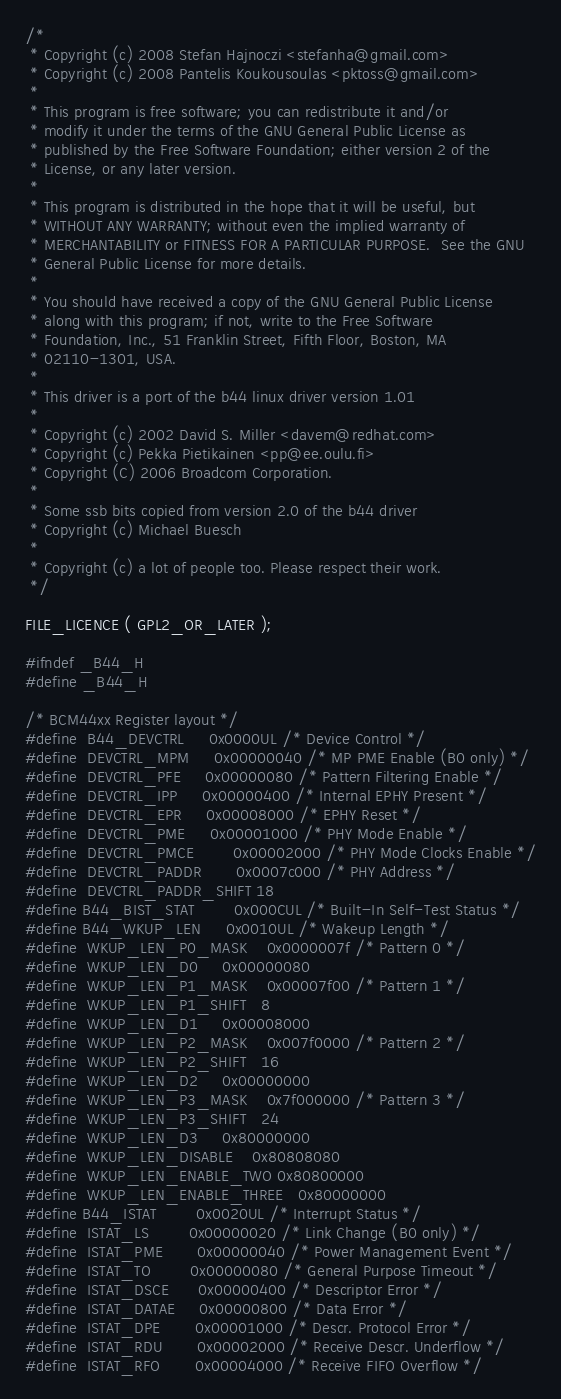<code> <loc_0><loc_0><loc_500><loc_500><_C_>/*
 * Copyright (c) 2008 Stefan Hajnoczi <stefanha@gmail.com>
 * Copyright (c) 2008 Pantelis Koukousoulas <pktoss@gmail.com>
 *
 * This program is free software; you can redistribute it and/or
 * modify it under the terms of the GNU General Public License as
 * published by the Free Software Foundation; either version 2 of the
 * License, or any later version.
 *
 * This program is distributed in the hope that it will be useful, but
 * WITHOUT ANY WARRANTY; without even the implied warranty of
 * MERCHANTABILITY or FITNESS FOR A PARTICULAR PURPOSE.  See the GNU
 * General Public License for more details.
 *
 * You should have received a copy of the GNU General Public License
 * along with this program; if not, write to the Free Software
 * Foundation, Inc., 51 Franklin Street, Fifth Floor, Boston, MA
 * 02110-1301, USA.
 *
 * This driver is a port of the b44 linux driver version 1.01
 *
 * Copyright (c) 2002 David S. Miller <davem@redhat.com>
 * Copyright (c) Pekka Pietikainen <pp@ee.oulu.fi>
 * Copyright (C) 2006 Broadcom Corporation.
 *
 * Some ssb bits copied from version 2.0 of the b44 driver
 * Copyright (c) Michael Buesch
 *
 * Copyright (c) a lot of people too. Please respect their work.
 */

FILE_LICENCE ( GPL2_OR_LATER );

#ifndef _B44_H
#define _B44_H

/* BCM44xx Register layout */
#define	B44_DEVCTRL		0x0000UL /* Device Control */
#define  DEVCTRL_MPM		0x00000040 /* MP PME Enable (B0 only) */
#define  DEVCTRL_PFE		0x00000080 /* Pattern Filtering Enable */
#define  DEVCTRL_IPP		0x00000400 /* Internal EPHY Present */
#define  DEVCTRL_EPR		0x00008000 /* EPHY Reset */
#define  DEVCTRL_PME		0x00001000 /* PHY Mode Enable */
#define  DEVCTRL_PMCE		0x00002000 /* PHY Mode Clocks Enable */
#define  DEVCTRL_PADDR		0x0007c000 /* PHY Address */
#define  DEVCTRL_PADDR_SHIFT	18
#define B44_BIST_STAT		0x000CUL /* Built-In Self-Test Status */
#define B44_WKUP_LEN		0x0010UL /* Wakeup Length */
#define  WKUP_LEN_P0_MASK	0x0000007f /* Pattern 0 */
#define  WKUP_LEN_D0		0x00000080
#define  WKUP_LEN_P1_MASK	0x00007f00 /* Pattern 1 */
#define  WKUP_LEN_P1_SHIFT	8
#define  WKUP_LEN_D1		0x00008000
#define  WKUP_LEN_P2_MASK	0x007f0000 /* Pattern 2 */
#define  WKUP_LEN_P2_SHIFT	16
#define  WKUP_LEN_D2		0x00000000
#define  WKUP_LEN_P3_MASK	0x7f000000 /* Pattern 3 */
#define  WKUP_LEN_P3_SHIFT	24
#define  WKUP_LEN_D3		0x80000000
#define  WKUP_LEN_DISABLE	0x80808080
#define  WKUP_LEN_ENABLE_TWO	0x80800000
#define  WKUP_LEN_ENABLE_THREE	0x80000000
#define B44_ISTAT		0x0020UL /* Interrupt Status */
#define  ISTAT_LS		0x00000020 /* Link Change (B0 only) */
#define  ISTAT_PME		0x00000040 /* Power Management Event */
#define  ISTAT_TO		0x00000080 /* General Purpose Timeout */
#define  ISTAT_DSCE		0x00000400 /* Descriptor Error */
#define  ISTAT_DATAE		0x00000800 /* Data Error */
#define  ISTAT_DPE		0x00001000 /* Descr. Protocol Error */
#define  ISTAT_RDU		0x00002000 /* Receive Descr. Underflow */
#define  ISTAT_RFO		0x00004000 /* Receive FIFO Overflow */</code> 